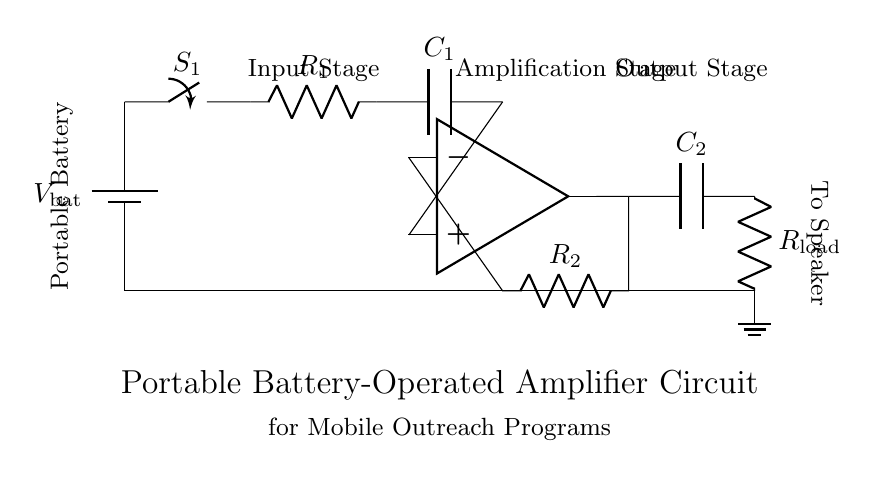What is the function of the switch in this circuit? The switch is used to turn the circuit on or off, controlling the flow of current from the battery to the amplifier.
Answer: To turn the circuit on or off What type of amplifier is represented in the circuit? The circuit includes an operational amplifier, indicated by the op-amp symbol drawn in the center.
Answer: Operational amplifier What are the roles of resistors R1 and R2? R1 is part of the input stage that helps limit the current, while R2 is used in the feedback loop of the amplifier to control gain.
Answer: Current limiting and gain control How many capacitors are used in the circuit? There are two capacitors labeled C1 and C2, which are used for coupling and filtering signals in the amplifier stage.
Answer: Two What is the significance of using a portable battery? The portable battery provides power to the amplifier circuit, allowing for mobility in outreach programs without reliance on fixed power sources.
Answer: Mobility of the circuit What is the load in this amplifier circuit? The load is represented by Rload which corresponds to the connected speaker that will receive the amplified signal.
Answer: Speaker 